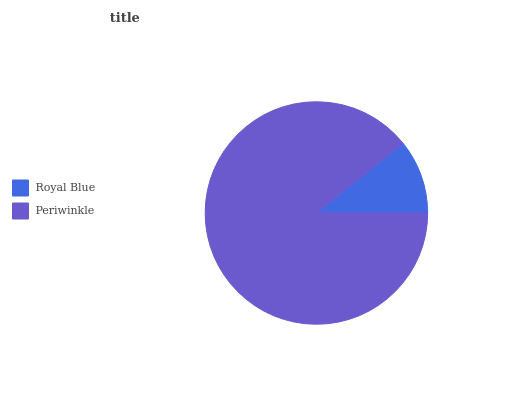Is Royal Blue the minimum?
Answer yes or no. Yes. Is Periwinkle the maximum?
Answer yes or no. Yes. Is Periwinkle the minimum?
Answer yes or no. No. Is Periwinkle greater than Royal Blue?
Answer yes or no. Yes. Is Royal Blue less than Periwinkle?
Answer yes or no. Yes. Is Royal Blue greater than Periwinkle?
Answer yes or no. No. Is Periwinkle less than Royal Blue?
Answer yes or no. No. Is Periwinkle the high median?
Answer yes or no. Yes. Is Royal Blue the low median?
Answer yes or no. Yes. Is Royal Blue the high median?
Answer yes or no. No. Is Periwinkle the low median?
Answer yes or no. No. 